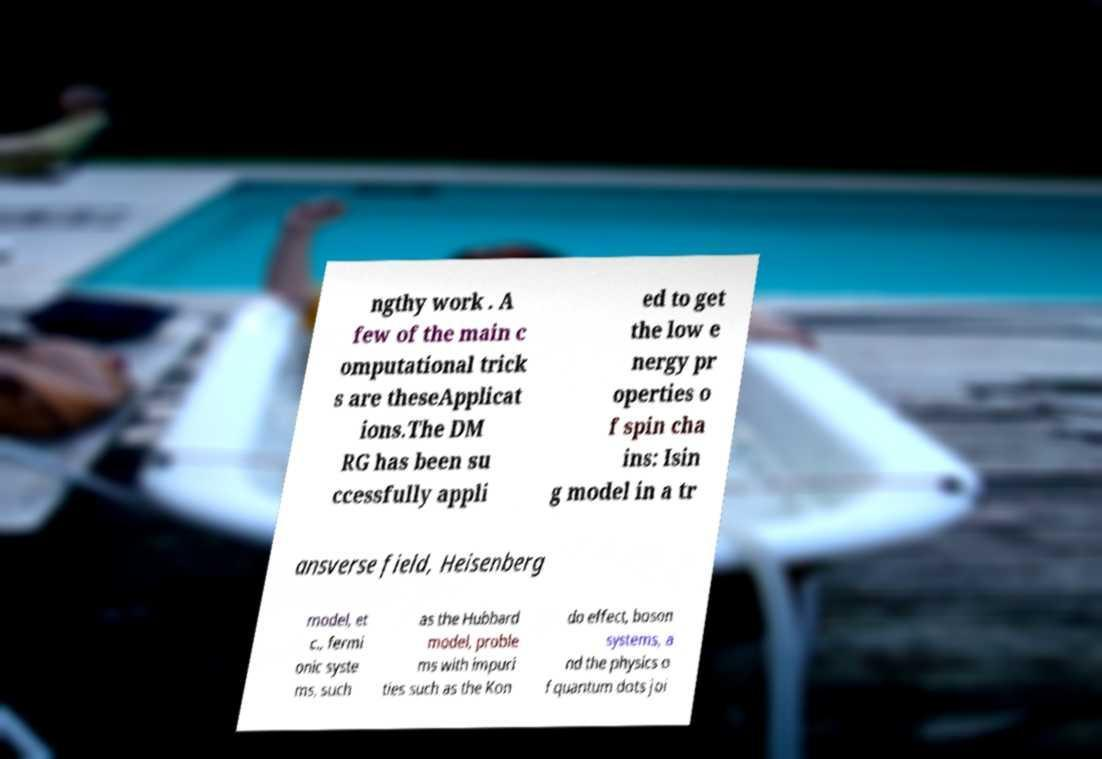Can you read and provide the text displayed in the image?This photo seems to have some interesting text. Can you extract and type it out for me? ngthy work . A few of the main c omputational trick s are theseApplicat ions.The DM RG has been su ccessfully appli ed to get the low e nergy pr operties o f spin cha ins: Isin g model in a tr ansverse field, Heisenberg model, et c., fermi onic syste ms, such as the Hubbard model, proble ms with impuri ties such as the Kon do effect, boson systems, a nd the physics o f quantum dots joi 